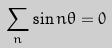<formula> <loc_0><loc_0><loc_500><loc_500>\sum _ { n } \sin n \theta = 0</formula> 